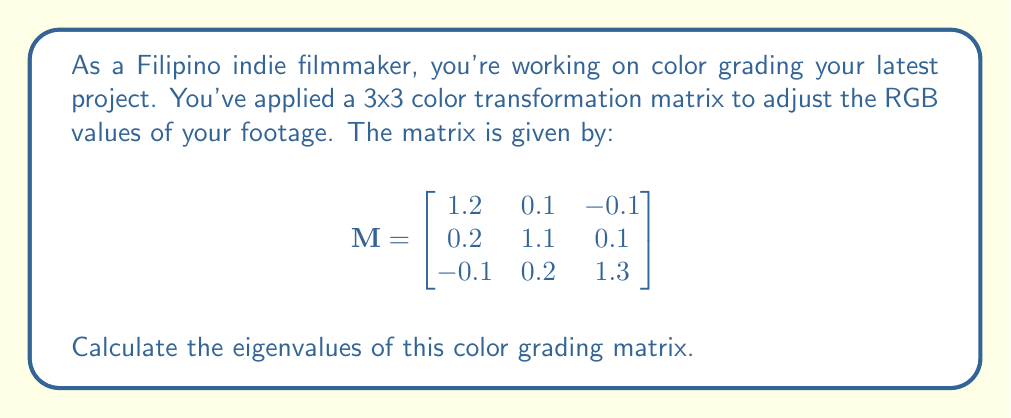Teach me how to tackle this problem. To find the eigenvalues of matrix M, we need to solve the characteristic equation:

$$\det(M - \lambda I) = 0$$

Where $\lambda$ represents the eigenvalues and I is the 3x3 identity matrix.

Step 1: Set up the characteristic equation:
$$\det\begin{pmatrix}
1.2 - \lambda & 0.1 & -0.1 \\
0.2 & 1.1 - \lambda & 0.1 \\
-0.1 & 0.2 & 1.3 - \lambda
\end{pmatrix} = 0$$

Step 2: Calculate the determinant:
$$(1.2 - \lambda)[(1.1 - \lambda)(1.3 - \lambda) - 0.02] - 0.1[0.2(1.3 - \lambda) - 0.01] + (-0.1)[0.2(1.1 - \lambda) - 0.02] = 0$$

Step 3: Expand and simplify:
$$\lambda^3 - 3.6\lambda^2 + 4.31\lambda - 1.716 = 0$$

Step 4: Solve the cubic equation. This can be done using various methods such as the cubic formula or numerical methods. Using a computer algebra system, we find the roots:

$$\lambda_1 \approx 1.5$$
$$\lambda_2 \approx 1.1$$
$$\lambda_3 \approx 1.0$$
Answer: $\lambda_1 \approx 1.5$, $\lambda_2 \approx 1.1$, $\lambda_3 \approx 1.0$ 